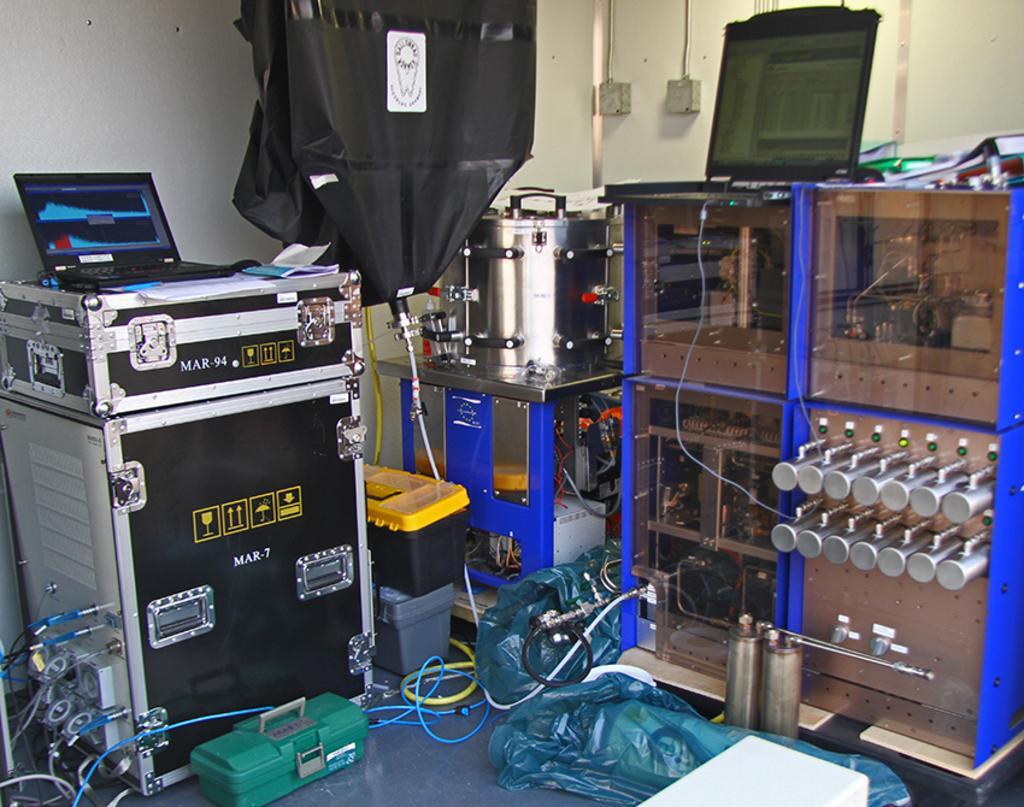How would you summarize this image in a sentence or two? This is an inside picture of the room, we can see some electronic instruments, like, cupboard with some objects on it and a laptop, there are some boxes, cables, machine and some other objects on the floor, also we can see the wall. 